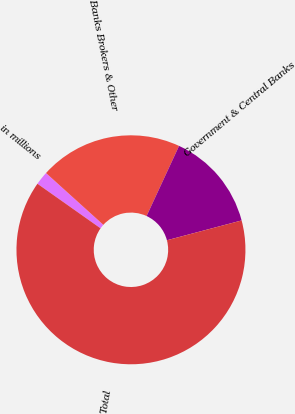Convert chart to OTSL. <chart><loc_0><loc_0><loc_500><loc_500><pie_chart><fcel>in millions<fcel>Banks Brokers & Other<fcel>Government & Central Banks<fcel>Total<nl><fcel>1.91%<fcel>20.21%<fcel>13.97%<fcel>63.92%<nl></chart> 